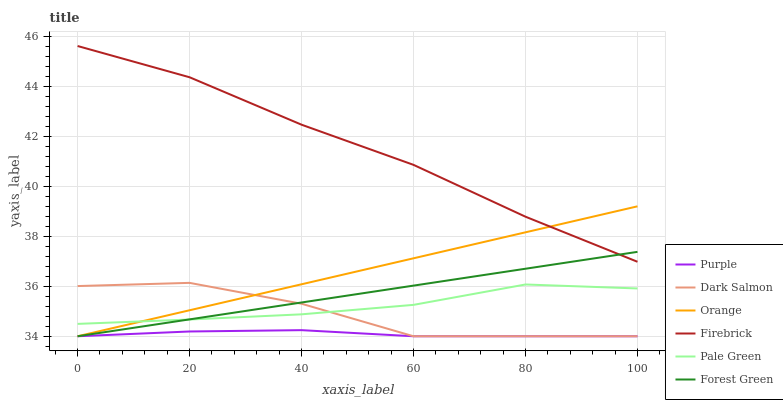Does Purple have the minimum area under the curve?
Answer yes or no. Yes. Does Firebrick have the maximum area under the curve?
Answer yes or no. Yes. Does Dark Salmon have the minimum area under the curve?
Answer yes or no. No. Does Dark Salmon have the maximum area under the curve?
Answer yes or no. No. Is Forest Green the smoothest?
Answer yes or no. Yes. Is Dark Salmon the roughest?
Answer yes or no. Yes. Is Firebrick the smoothest?
Answer yes or no. No. Is Firebrick the roughest?
Answer yes or no. No. Does Purple have the lowest value?
Answer yes or no. Yes. Does Firebrick have the lowest value?
Answer yes or no. No. Does Firebrick have the highest value?
Answer yes or no. Yes. Does Dark Salmon have the highest value?
Answer yes or no. No. Is Purple less than Firebrick?
Answer yes or no. Yes. Is Firebrick greater than Pale Green?
Answer yes or no. Yes. Does Purple intersect Orange?
Answer yes or no. Yes. Is Purple less than Orange?
Answer yes or no. No. Is Purple greater than Orange?
Answer yes or no. No. Does Purple intersect Firebrick?
Answer yes or no. No. 